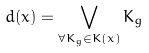Convert formula to latex. <formula><loc_0><loc_0><loc_500><loc_500>d ( x ) = \bigvee _ { \forall K _ { g } \in K ( x ) } K _ { g }</formula> 